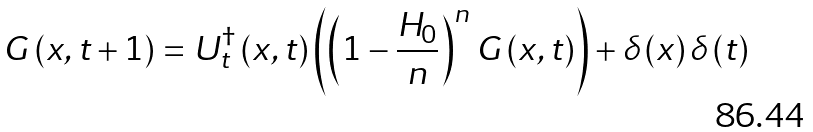Convert formula to latex. <formula><loc_0><loc_0><loc_500><loc_500>G \left ( x , t + 1 \right ) = U ^ { \dagger } _ { t } \left ( x , t \right ) \left ( \left ( 1 - \frac { H _ { 0 } } { n } \right ) ^ { n } G \left ( x , t \right ) \right ) + \delta \left ( x \right ) \delta \left ( t \right )</formula> 